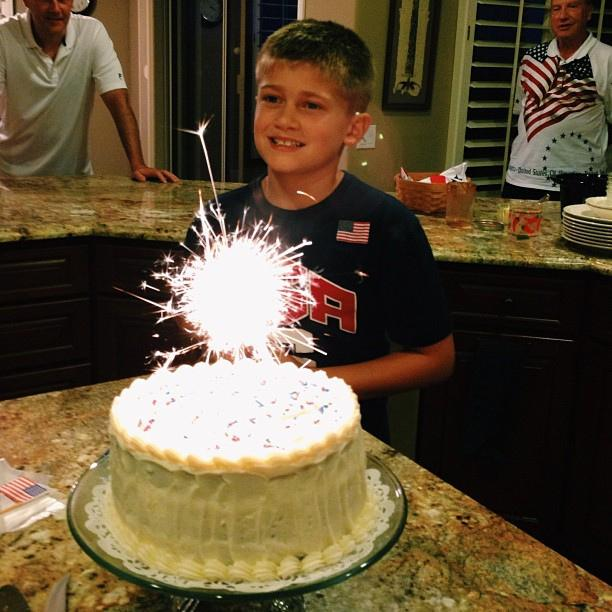What holiday is this cake likeliest to commemorate? Please explain your reasoning. 4th july. The cake is for the fourth of july. 